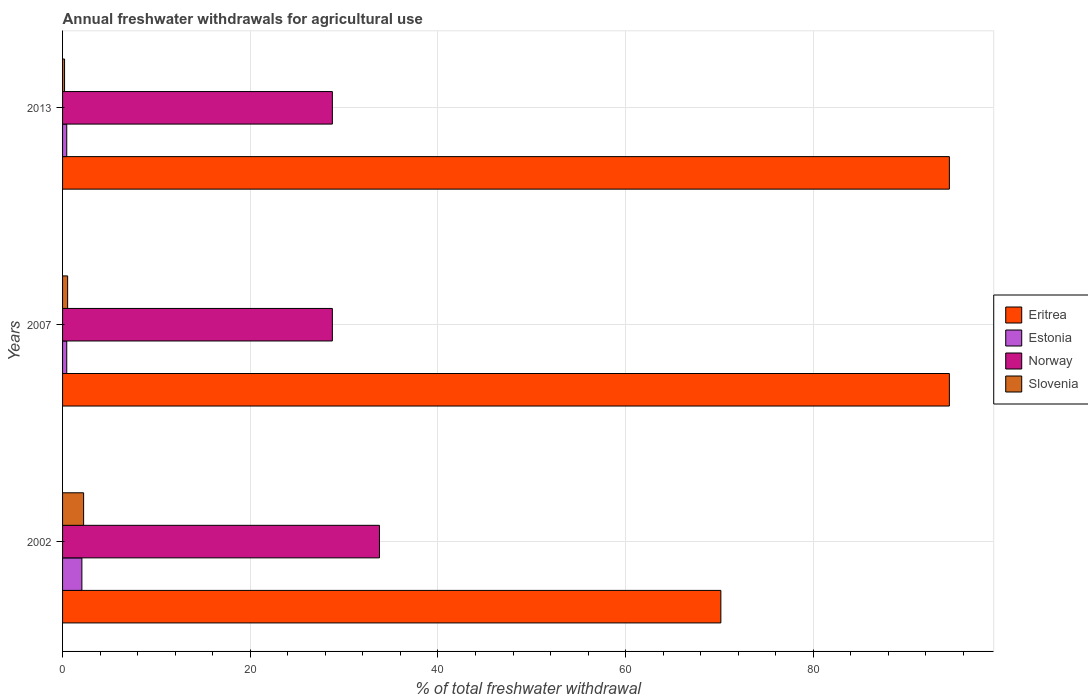Are the number of bars per tick equal to the number of legend labels?
Ensure brevity in your answer.  Yes. Are the number of bars on each tick of the Y-axis equal?
Make the answer very short. Yes. How many bars are there on the 1st tick from the top?
Your answer should be compact. 4. How many bars are there on the 1st tick from the bottom?
Offer a very short reply. 4. What is the label of the 2nd group of bars from the top?
Your response must be concise. 2007. What is the total annual withdrawals from freshwater in Slovenia in 2002?
Keep it short and to the point. 2.24. Across all years, what is the maximum total annual withdrawals from freshwater in Slovenia?
Your answer should be very brief. 2.24. Across all years, what is the minimum total annual withdrawals from freshwater in Eritrea?
Offer a terse response. 70.15. In which year was the total annual withdrawals from freshwater in Norway maximum?
Keep it short and to the point. 2002. What is the total total annual withdrawals from freshwater in Eritrea in the graph?
Provide a succinct answer. 259.15. What is the difference between the total annual withdrawals from freshwater in Norway in 2002 and that in 2013?
Make the answer very short. 5.02. What is the difference between the total annual withdrawals from freshwater in Estonia in 2013 and the total annual withdrawals from freshwater in Eritrea in 2002?
Your answer should be very brief. -69.7. What is the average total annual withdrawals from freshwater in Slovenia per year?
Your answer should be very brief. 1. In the year 2013, what is the difference between the total annual withdrawals from freshwater in Eritrea and total annual withdrawals from freshwater in Norway?
Provide a short and direct response. 65.75. What is the difference between the highest and the second highest total annual withdrawals from freshwater in Norway?
Provide a succinct answer. 5.02. What is the difference between the highest and the lowest total annual withdrawals from freshwater in Norway?
Your answer should be compact. 5.02. Is the sum of the total annual withdrawals from freshwater in Eritrea in 2002 and 2013 greater than the maximum total annual withdrawals from freshwater in Norway across all years?
Your answer should be compact. Yes. Is it the case that in every year, the sum of the total annual withdrawals from freshwater in Eritrea and total annual withdrawals from freshwater in Slovenia is greater than the sum of total annual withdrawals from freshwater in Norway and total annual withdrawals from freshwater in Estonia?
Make the answer very short. Yes. What does the 4th bar from the top in 2002 represents?
Ensure brevity in your answer.  Eritrea. What does the 1st bar from the bottom in 2002 represents?
Ensure brevity in your answer.  Eritrea. Is it the case that in every year, the sum of the total annual withdrawals from freshwater in Estonia and total annual withdrawals from freshwater in Norway is greater than the total annual withdrawals from freshwater in Eritrea?
Your response must be concise. No. How many bars are there?
Give a very brief answer. 12. Does the graph contain any zero values?
Your response must be concise. No. Where does the legend appear in the graph?
Offer a very short reply. Center right. What is the title of the graph?
Make the answer very short. Annual freshwater withdrawals for agricultural use. What is the label or title of the X-axis?
Make the answer very short. % of total freshwater withdrawal. What is the % of total freshwater withdrawal in Eritrea in 2002?
Provide a short and direct response. 70.15. What is the % of total freshwater withdrawal of Estonia in 2002?
Make the answer very short. 2.06. What is the % of total freshwater withdrawal in Norway in 2002?
Keep it short and to the point. 33.77. What is the % of total freshwater withdrawal in Slovenia in 2002?
Provide a succinct answer. 2.24. What is the % of total freshwater withdrawal of Eritrea in 2007?
Your answer should be compact. 94.5. What is the % of total freshwater withdrawal of Estonia in 2007?
Ensure brevity in your answer.  0.45. What is the % of total freshwater withdrawal of Norway in 2007?
Make the answer very short. 28.75. What is the % of total freshwater withdrawal of Slovenia in 2007?
Your answer should be very brief. 0.54. What is the % of total freshwater withdrawal in Eritrea in 2013?
Your answer should be compact. 94.5. What is the % of total freshwater withdrawal of Estonia in 2013?
Make the answer very short. 0.45. What is the % of total freshwater withdrawal in Norway in 2013?
Your answer should be compact. 28.75. What is the % of total freshwater withdrawal of Slovenia in 2013?
Ensure brevity in your answer.  0.21. Across all years, what is the maximum % of total freshwater withdrawal of Eritrea?
Your answer should be compact. 94.5. Across all years, what is the maximum % of total freshwater withdrawal in Estonia?
Make the answer very short. 2.06. Across all years, what is the maximum % of total freshwater withdrawal in Norway?
Give a very brief answer. 33.77. Across all years, what is the maximum % of total freshwater withdrawal of Slovenia?
Offer a very short reply. 2.24. Across all years, what is the minimum % of total freshwater withdrawal in Eritrea?
Ensure brevity in your answer.  70.15. Across all years, what is the minimum % of total freshwater withdrawal in Estonia?
Your answer should be very brief. 0.45. Across all years, what is the minimum % of total freshwater withdrawal in Norway?
Provide a succinct answer. 28.75. Across all years, what is the minimum % of total freshwater withdrawal in Slovenia?
Your answer should be compact. 0.21. What is the total % of total freshwater withdrawal in Eritrea in the graph?
Your response must be concise. 259.15. What is the total % of total freshwater withdrawal of Estonia in the graph?
Provide a short and direct response. 2.95. What is the total % of total freshwater withdrawal in Norway in the graph?
Keep it short and to the point. 91.27. What is the total % of total freshwater withdrawal of Slovenia in the graph?
Make the answer very short. 3. What is the difference between the % of total freshwater withdrawal in Eritrea in 2002 and that in 2007?
Give a very brief answer. -24.35. What is the difference between the % of total freshwater withdrawal of Estonia in 2002 and that in 2007?
Provide a succinct answer. 1.61. What is the difference between the % of total freshwater withdrawal of Norway in 2002 and that in 2007?
Your answer should be compact. 5.02. What is the difference between the % of total freshwater withdrawal in Slovenia in 2002 and that in 2007?
Your answer should be compact. 1.7. What is the difference between the % of total freshwater withdrawal of Eritrea in 2002 and that in 2013?
Provide a short and direct response. -24.35. What is the difference between the % of total freshwater withdrawal of Estonia in 2002 and that in 2013?
Your response must be concise. 1.61. What is the difference between the % of total freshwater withdrawal of Norway in 2002 and that in 2013?
Give a very brief answer. 5.02. What is the difference between the % of total freshwater withdrawal in Slovenia in 2002 and that in 2013?
Your answer should be compact. 2.03. What is the difference between the % of total freshwater withdrawal of Eritrea in 2007 and that in 2013?
Your answer should be very brief. 0. What is the difference between the % of total freshwater withdrawal of Norway in 2007 and that in 2013?
Your answer should be compact. 0. What is the difference between the % of total freshwater withdrawal in Slovenia in 2007 and that in 2013?
Your response must be concise. 0.33. What is the difference between the % of total freshwater withdrawal of Eritrea in 2002 and the % of total freshwater withdrawal of Estonia in 2007?
Make the answer very short. 69.7. What is the difference between the % of total freshwater withdrawal of Eritrea in 2002 and the % of total freshwater withdrawal of Norway in 2007?
Give a very brief answer. 41.4. What is the difference between the % of total freshwater withdrawal in Eritrea in 2002 and the % of total freshwater withdrawal in Slovenia in 2007?
Your response must be concise. 69.61. What is the difference between the % of total freshwater withdrawal in Estonia in 2002 and the % of total freshwater withdrawal in Norway in 2007?
Provide a short and direct response. -26.69. What is the difference between the % of total freshwater withdrawal in Estonia in 2002 and the % of total freshwater withdrawal in Slovenia in 2007?
Keep it short and to the point. 1.52. What is the difference between the % of total freshwater withdrawal of Norway in 2002 and the % of total freshwater withdrawal of Slovenia in 2007?
Offer a terse response. 33.23. What is the difference between the % of total freshwater withdrawal of Eritrea in 2002 and the % of total freshwater withdrawal of Estonia in 2013?
Give a very brief answer. 69.7. What is the difference between the % of total freshwater withdrawal of Eritrea in 2002 and the % of total freshwater withdrawal of Norway in 2013?
Your answer should be compact. 41.4. What is the difference between the % of total freshwater withdrawal of Eritrea in 2002 and the % of total freshwater withdrawal of Slovenia in 2013?
Give a very brief answer. 69.94. What is the difference between the % of total freshwater withdrawal in Estonia in 2002 and the % of total freshwater withdrawal in Norway in 2013?
Provide a short and direct response. -26.69. What is the difference between the % of total freshwater withdrawal in Estonia in 2002 and the % of total freshwater withdrawal in Slovenia in 2013?
Offer a very short reply. 1.85. What is the difference between the % of total freshwater withdrawal of Norway in 2002 and the % of total freshwater withdrawal of Slovenia in 2013?
Your answer should be compact. 33.56. What is the difference between the % of total freshwater withdrawal in Eritrea in 2007 and the % of total freshwater withdrawal in Estonia in 2013?
Give a very brief answer. 94.05. What is the difference between the % of total freshwater withdrawal of Eritrea in 2007 and the % of total freshwater withdrawal of Norway in 2013?
Ensure brevity in your answer.  65.75. What is the difference between the % of total freshwater withdrawal in Eritrea in 2007 and the % of total freshwater withdrawal in Slovenia in 2013?
Your answer should be very brief. 94.29. What is the difference between the % of total freshwater withdrawal in Estonia in 2007 and the % of total freshwater withdrawal in Norway in 2013?
Your answer should be very brief. -28.3. What is the difference between the % of total freshwater withdrawal of Estonia in 2007 and the % of total freshwater withdrawal of Slovenia in 2013?
Your answer should be compact. 0.23. What is the difference between the % of total freshwater withdrawal in Norway in 2007 and the % of total freshwater withdrawal in Slovenia in 2013?
Your answer should be very brief. 28.54. What is the average % of total freshwater withdrawal in Eritrea per year?
Keep it short and to the point. 86.38. What is the average % of total freshwater withdrawal in Estonia per year?
Provide a short and direct response. 0.98. What is the average % of total freshwater withdrawal of Norway per year?
Offer a very short reply. 30.42. What is the average % of total freshwater withdrawal of Slovenia per year?
Provide a short and direct response. 1. In the year 2002, what is the difference between the % of total freshwater withdrawal in Eritrea and % of total freshwater withdrawal in Estonia?
Provide a succinct answer. 68.09. In the year 2002, what is the difference between the % of total freshwater withdrawal in Eritrea and % of total freshwater withdrawal in Norway?
Give a very brief answer. 36.38. In the year 2002, what is the difference between the % of total freshwater withdrawal in Eritrea and % of total freshwater withdrawal in Slovenia?
Your answer should be compact. 67.91. In the year 2002, what is the difference between the % of total freshwater withdrawal of Estonia and % of total freshwater withdrawal of Norway?
Your answer should be very brief. -31.71. In the year 2002, what is the difference between the % of total freshwater withdrawal of Estonia and % of total freshwater withdrawal of Slovenia?
Give a very brief answer. -0.18. In the year 2002, what is the difference between the % of total freshwater withdrawal of Norway and % of total freshwater withdrawal of Slovenia?
Provide a short and direct response. 31.53. In the year 2007, what is the difference between the % of total freshwater withdrawal in Eritrea and % of total freshwater withdrawal in Estonia?
Your answer should be very brief. 94.05. In the year 2007, what is the difference between the % of total freshwater withdrawal in Eritrea and % of total freshwater withdrawal in Norway?
Make the answer very short. 65.75. In the year 2007, what is the difference between the % of total freshwater withdrawal in Eritrea and % of total freshwater withdrawal in Slovenia?
Make the answer very short. 93.96. In the year 2007, what is the difference between the % of total freshwater withdrawal of Estonia and % of total freshwater withdrawal of Norway?
Give a very brief answer. -28.3. In the year 2007, what is the difference between the % of total freshwater withdrawal in Estonia and % of total freshwater withdrawal in Slovenia?
Ensure brevity in your answer.  -0.09. In the year 2007, what is the difference between the % of total freshwater withdrawal in Norway and % of total freshwater withdrawal in Slovenia?
Provide a succinct answer. 28.21. In the year 2013, what is the difference between the % of total freshwater withdrawal of Eritrea and % of total freshwater withdrawal of Estonia?
Provide a succinct answer. 94.05. In the year 2013, what is the difference between the % of total freshwater withdrawal of Eritrea and % of total freshwater withdrawal of Norway?
Ensure brevity in your answer.  65.75. In the year 2013, what is the difference between the % of total freshwater withdrawal in Eritrea and % of total freshwater withdrawal in Slovenia?
Make the answer very short. 94.29. In the year 2013, what is the difference between the % of total freshwater withdrawal of Estonia and % of total freshwater withdrawal of Norway?
Make the answer very short. -28.3. In the year 2013, what is the difference between the % of total freshwater withdrawal in Estonia and % of total freshwater withdrawal in Slovenia?
Offer a terse response. 0.23. In the year 2013, what is the difference between the % of total freshwater withdrawal of Norway and % of total freshwater withdrawal of Slovenia?
Keep it short and to the point. 28.54. What is the ratio of the % of total freshwater withdrawal of Eritrea in 2002 to that in 2007?
Your answer should be compact. 0.74. What is the ratio of the % of total freshwater withdrawal of Estonia in 2002 to that in 2007?
Your answer should be compact. 4.63. What is the ratio of the % of total freshwater withdrawal in Norway in 2002 to that in 2007?
Your response must be concise. 1.17. What is the ratio of the % of total freshwater withdrawal of Slovenia in 2002 to that in 2007?
Your answer should be compact. 4.16. What is the ratio of the % of total freshwater withdrawal of Eritrea in 2002 to that in 2013?
Provide a short and direct response. 0.74. What is the ratio of the % of total freshwater withdrawal of Estonia in 2002 to that in 2013?
Ensure brevity in your answer.  4.63. What is the ratio of the % of total freshwater withdrawal in Norway in 2002 to that in 2013?
Provide a short and direct response. 1.17. What is the ratio of the % of total freshwater withdrawal in Slovenia in 2002 to that in 2013?
Ensure brevity in your answer.  10.57. What is the ratio of the % of total freshwater withdrawal in Eritrea in 2007 to that in 2013?
Provide a short and direct response. 1. What is the ratio of the % of total freshwater withdrawal in Norway in 2007 to that in 2013?
Provide a short and direct response. 1. What is the ratio of the % of total freshwater withdrawal of Slovenia in 2007 to that in 2013?
Ensure brevity in your answer.  2.54. What is the difference between the highest and the second highest % of total freshwater withdrawal in Estonia?
Offer a very short reply. 1.61. What is the difference between the highest and the second highest % of total freshwater withdrawal of Norway?
Offer a terse response. 5.02. What is the difference between the highest and the second highest % of total freshwater withdrawal of Slovenia?
Offer a very short reply. 1.7. What is the difference between the highest and the lowest % of total freshwater withdrawal in Eritrea?
Offer a very short reply. 24.35. What is the difference between the highest and the lowest % of total freshwater withdrawal in Estonia?
Provide a succinct answer. 1.61. What is the difference between the highest and the lowest % of total freshwater withdrawal in Norway?
Your answer should be compact. 5.02. What is the difference between the highest and the lowest % of total freshwater withdrawal of Slovenia?
Make the answer very short. 2.03. 